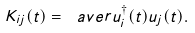Convert formula to latex. <formula><loc_0><loc_0><loc_500><loc_500>K _ { i j } ( t ) = \ a v e r { u _ { i } ^ { \dagger } ( t ) u _ { j } ( t ) } .</formula> 